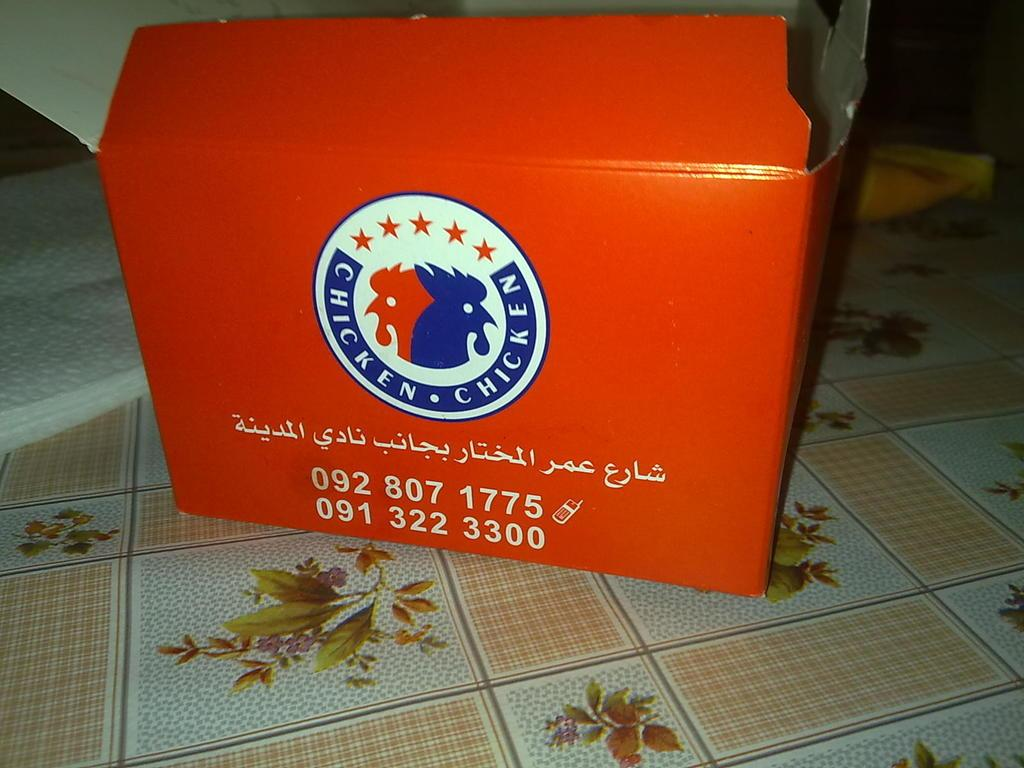<image>
Render a clear and concise summary of the photo. A large red box of chicken with a telephone number on the bottom 